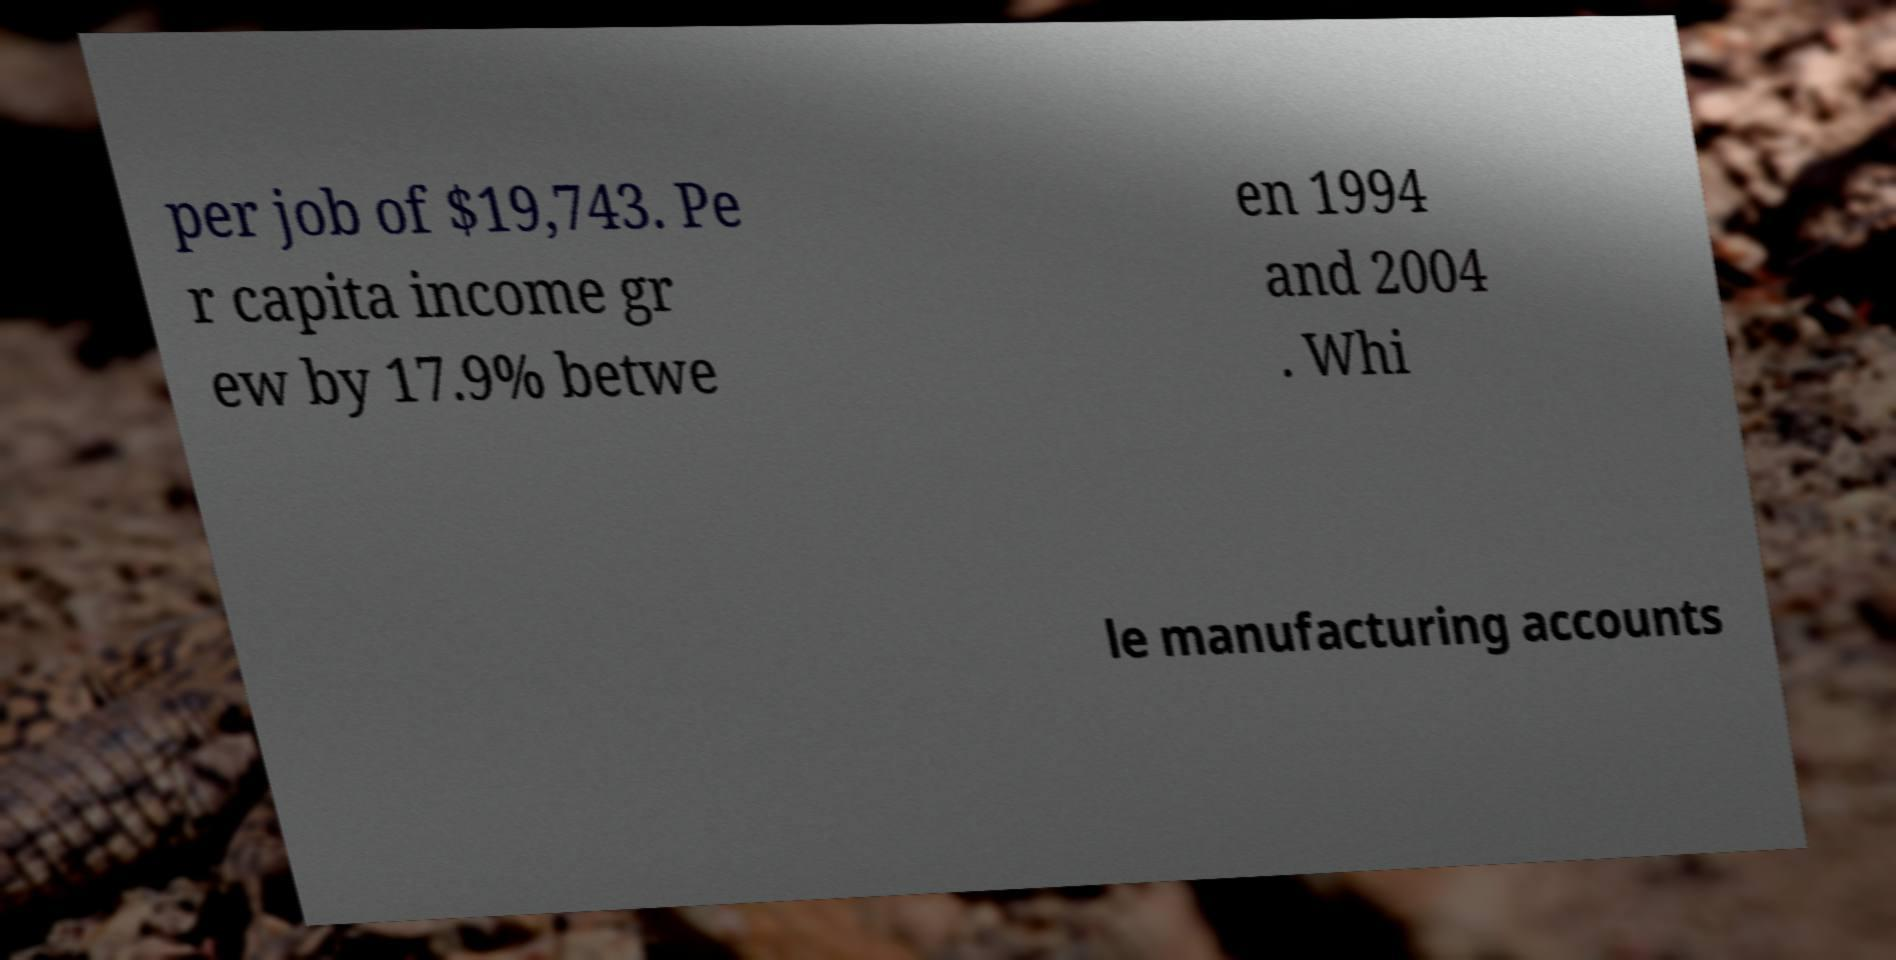What messages or text are displayed in this image? I need them in a readable, typed format. per job of $19,743. Pe r capita income gr ew by 17.9% betwe en 1994 and 2004 . Whi le manufacturing accounts 